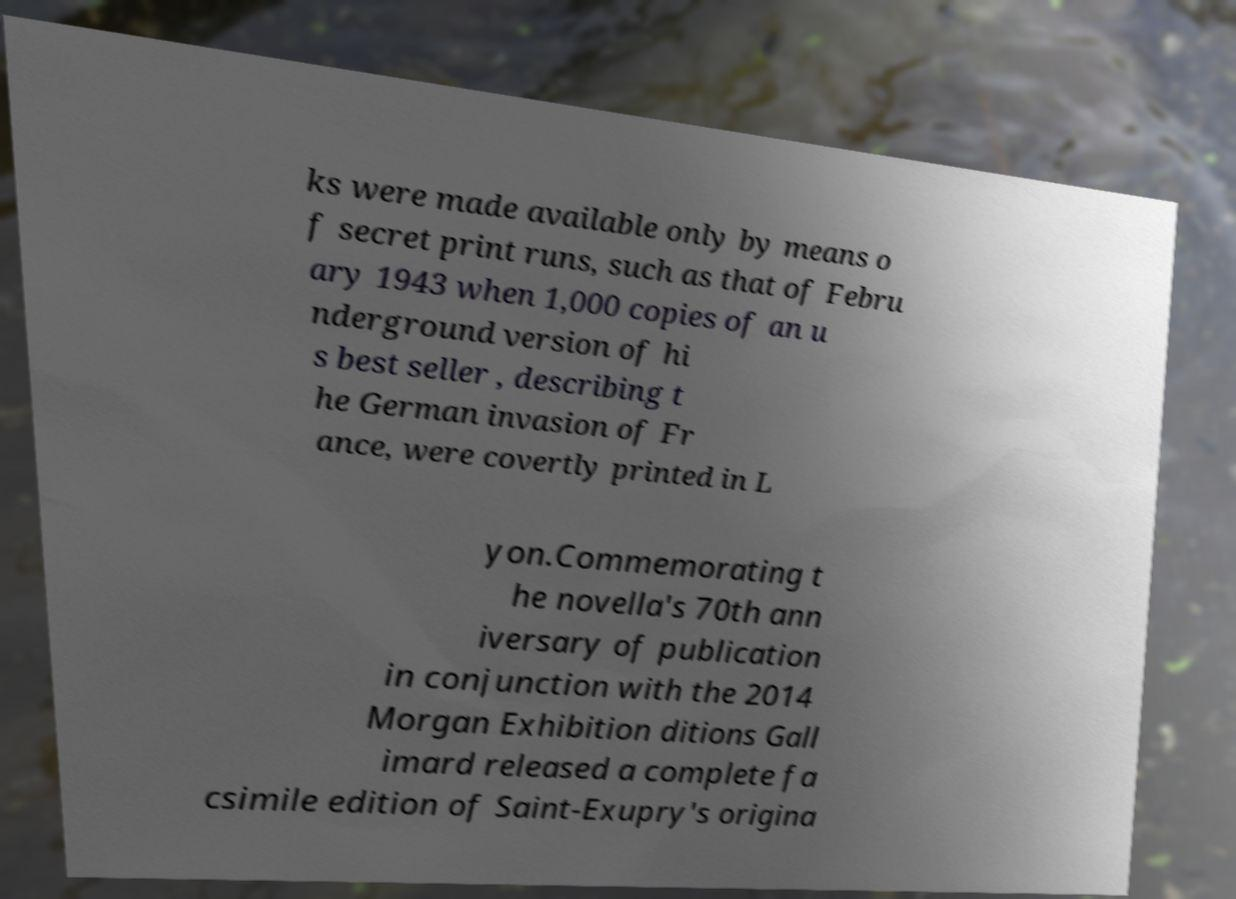Could you extract and type out the text from this image? ks were made available only by means o f secret print runs, such as that of Febru ary 1943 when 1,000 copies of an u nderground version of hi s best seller , describing t he German invasion of Fr ance, were covertly printed in L yon.Commemorating t he novella's 70th ann iversary of publication in conjunction with the 2014 Morgan Exhibition ditions Gall imard released a complete fa csimile edition of Saint-Exupry's origina 